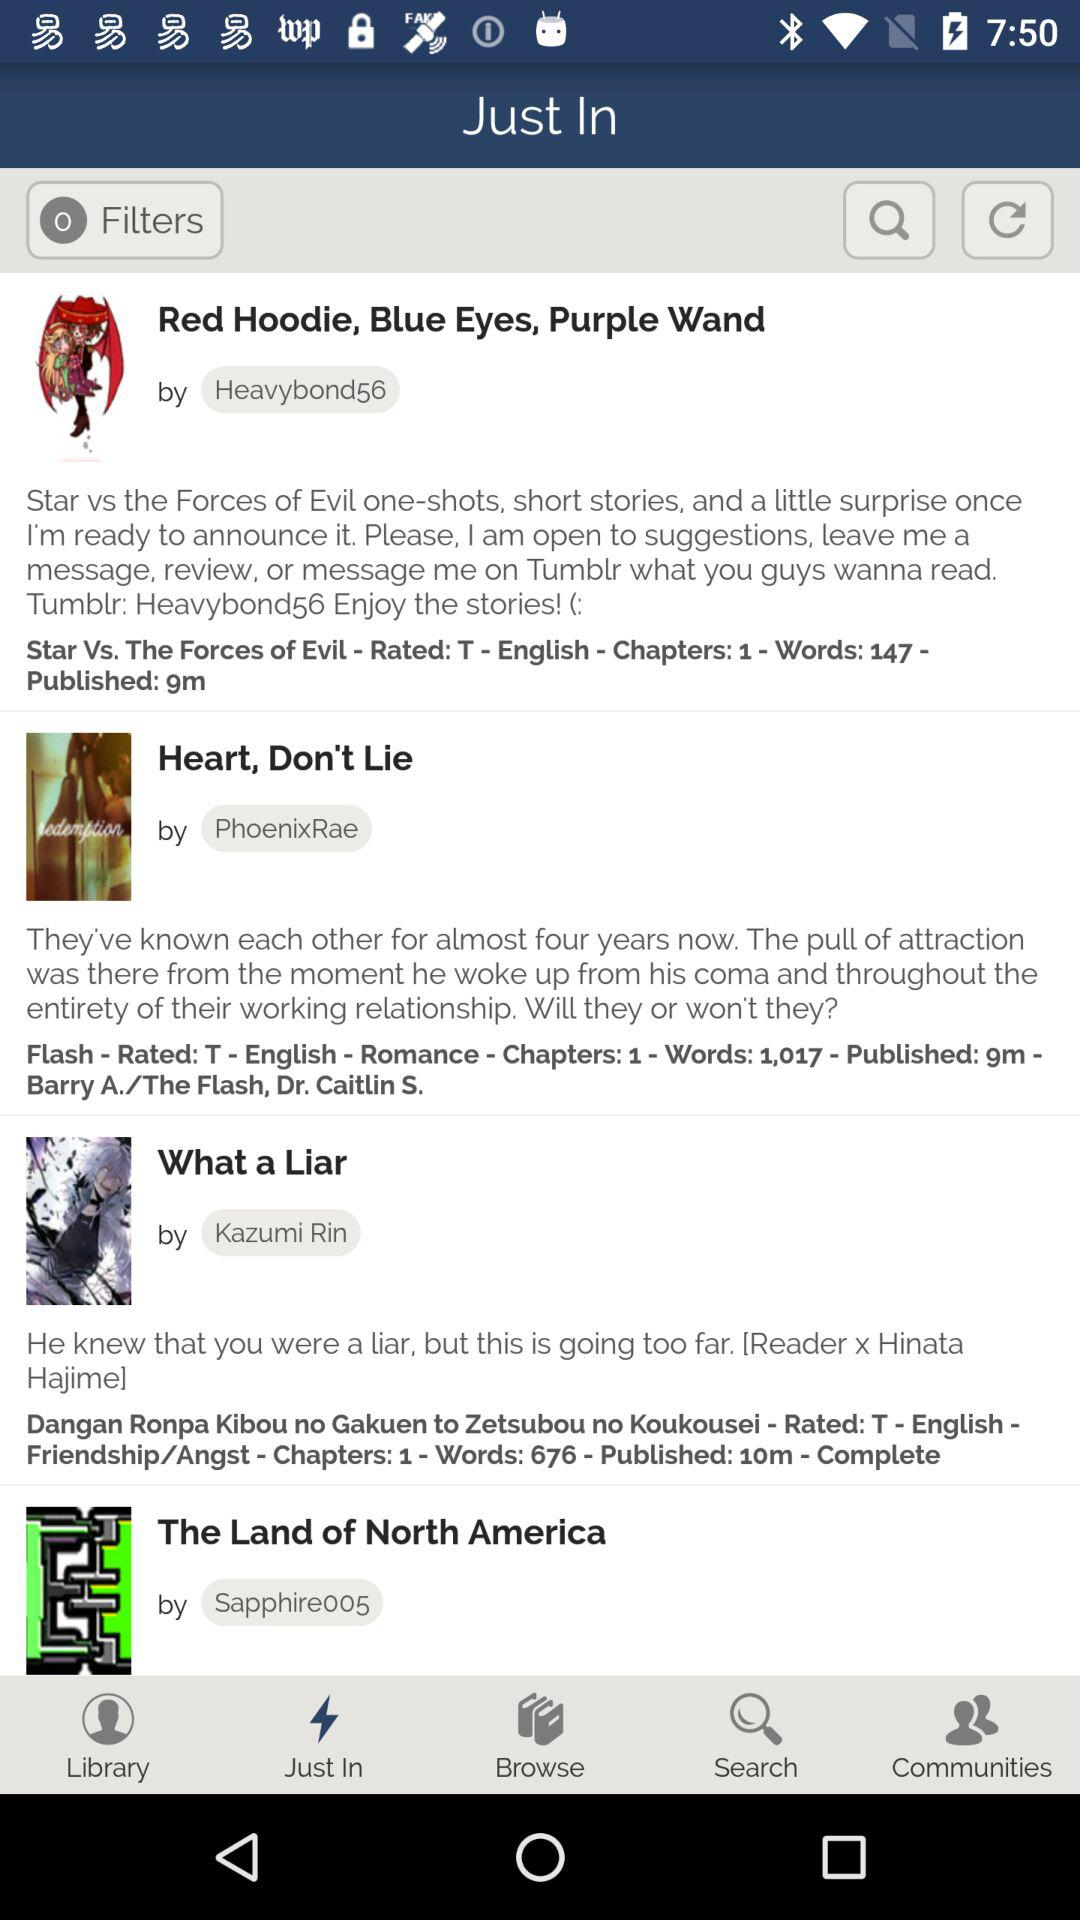What is the selected tab? The selected tab is "Just In". 